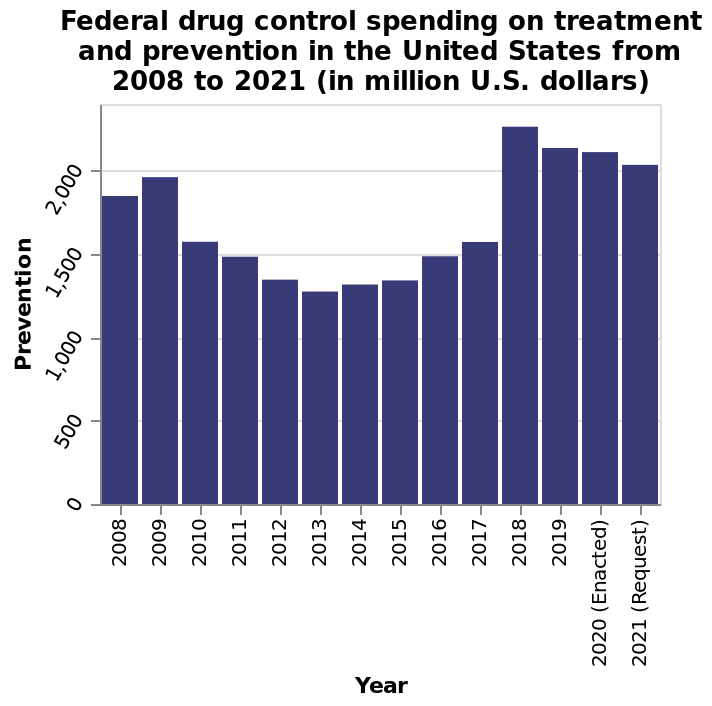<image>
When did the biggest year-on-year decline in spending occur?  The biggest year-on-year decline in spending occurred between 2009 and 2010. please describe the details of the chart This is a bar graph called Federal drug control spending on treatment and prevention in the United States from 2008 to 2021 (in million U.S. dollars). The x-axis measures Year as categorical scale with 2008 on one end and 2021 (Request) at the other while the y-axis plots Prevention as linear scale with a minimum of 0 and a maximum of 2,000. 